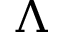Convert formula to latex. <formula><loc_0><loc_0><loc_500><loc_500>\Lambda</formula> 